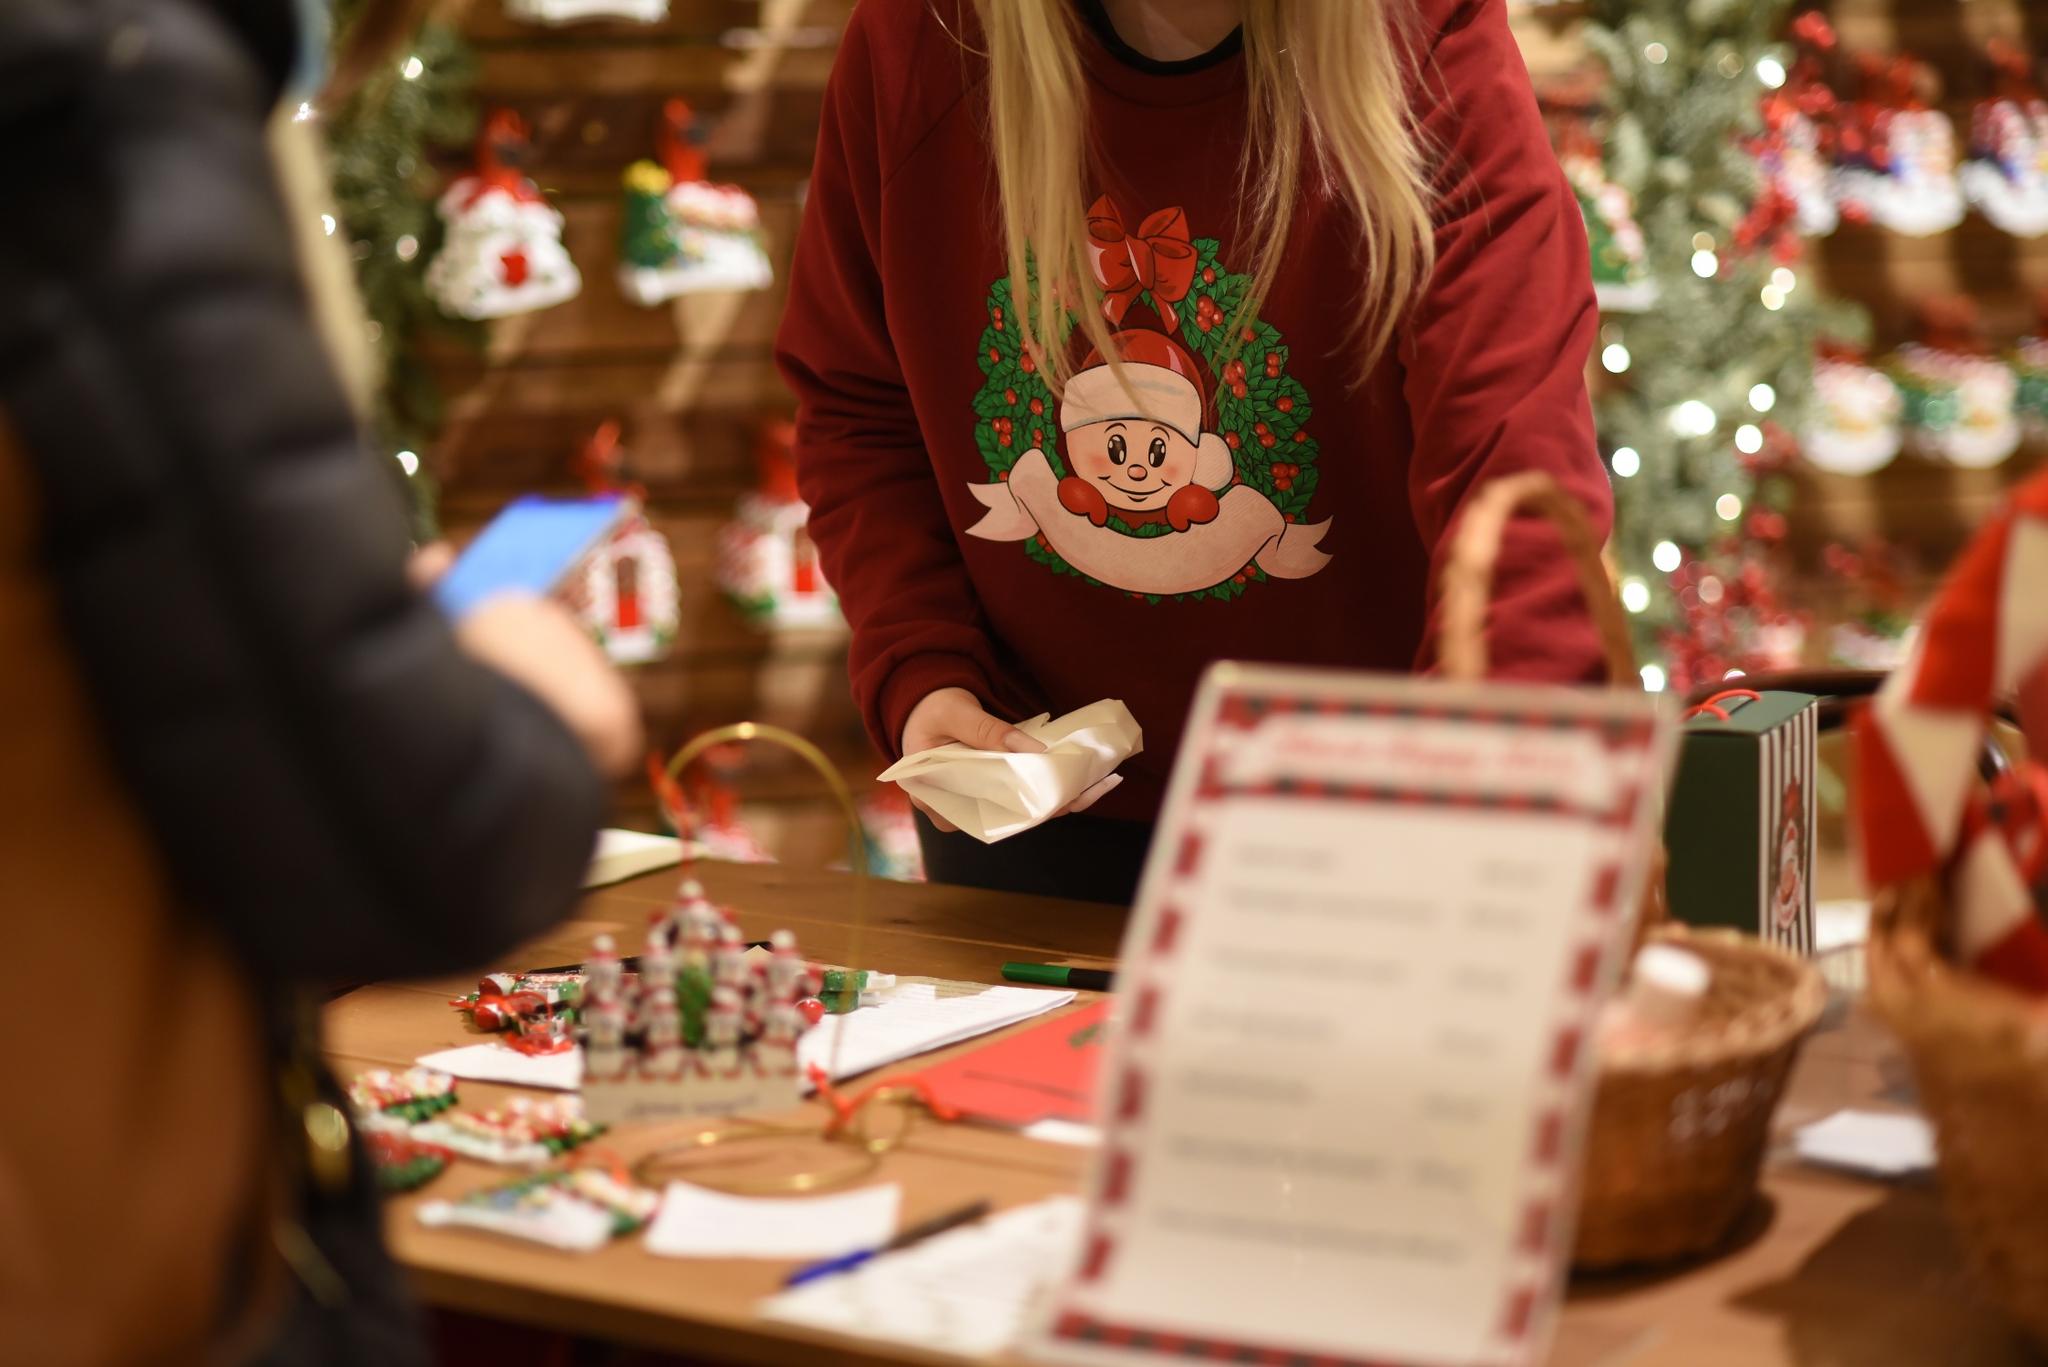Can you describe more details about the person's surroundings? Certainly! The surroundings in the image are bustling with festive holiday cheer. The wooden counter in front of the person is covered with an assortment of Christmas decorations and gift-wrapping accessories. Various ornaments, probably handmade or vintage-inspired, are scattered on the countertop, each adding a unique touch to the scene. The backdrop features a wooden wall adorned with an array of bright and colorful Christmas decorations, including miniature wreaths, stockings, and other ornaments. The overall setting suggests a bustling holiday market or a cozy Christmas shop filled with seasonal joy and preparations. 